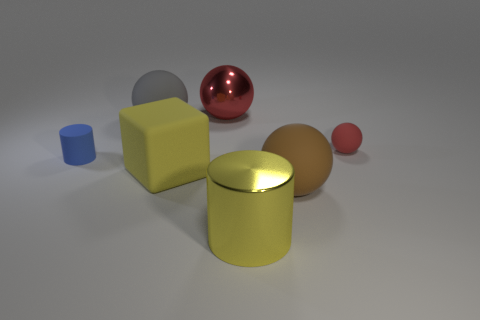What size is the brown rubber object that is the same shape as the large gray object?
Your answer should be compact. Large. What is the size of the other shiny sphere that is the same color as the tiny ball?
Give a very brief answer. Large. There is a object to the right of the large ball in front of the rubber ball that is on the left side of the big red shiny thing; what shape is it?
Your answer should be compact. Sphere. There is a metallic cylinder that is the same size as the brown rubber sphere; what color is it?
Provide a short and direct response. Yellow. What number of small rubber things have the same shape as the large brown object?
Make the answer very short. 1. There is a red metal object; is its size the same as the cylinder that is behind the yellow block?
Make the answer very short. No. What shape is the large shiny thing that is in front of the metal thing on the left side of the yellow metallic thing?
Provide a short and direct response. Cylinder. Is the number of blue matte objects that are behind the blue cylinder less than the number of red matte things?
Your answer should be compact. Yes. There is a tiny rubber object that is the same color as the big shiny ball; what is its shape?
Provide a succinct answer. Sphere. How many gray rubber objects are the same size as the yellow metallic object?
Your answer should be compact. 1. 